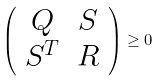<formula> <loc_0><loc_0><loc_500><loc_500>\left ( \begin{array} { c c } Q & S \\ S ^ { T } & R \end{array} \right ) \geq 0</formula> 